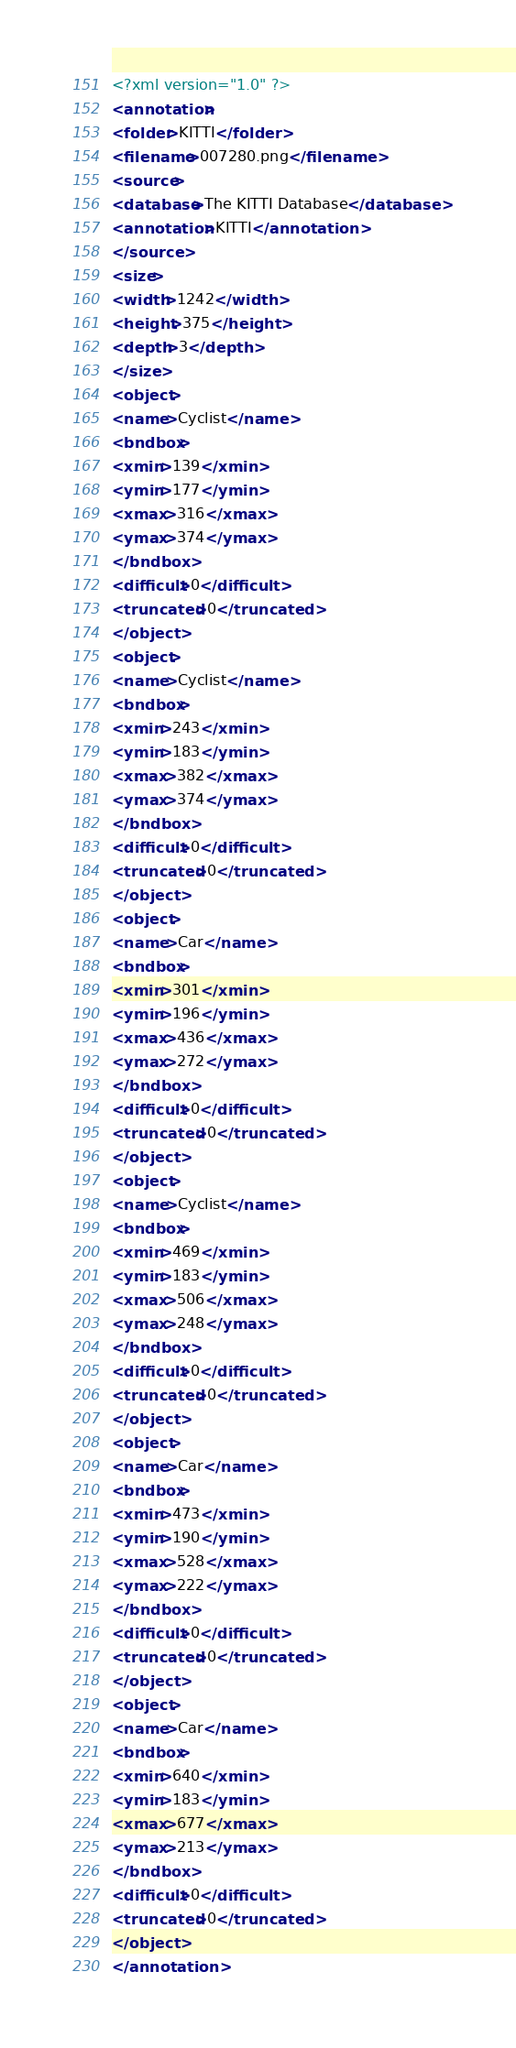Convert code to text. <code><loc_0><loc_0><loc_500><loc_500><_XML_><?xml version="1.0" ?>
<annotation>
<folder>KITTI</folder>
<filename>007280.png</filename>
<source>
<database>The KITTI Database</database>
<annotation>KITTI</annotation>
</source>
<size>
<width>1242</width>
<height>375</height>
<depth>3</depth>
</size>
<object>
<name>Cyclist</name>
<bndbox>
<xmin>139</xmin>
<ymin>177</ymin>
<xmax>316</xmax>
<ymax>374</ymax>
</bndbox>
<difficult>0</difficult>
<truncated>0</truncated>
</object>
<object>
<name>Cyclist</name>
<bndbox>
<xmin>243</xmin>
<ymin>183</ymin>
<xmax>382</xmax>
<ymax>374</ymax>
</bndbox>
<difficult>0</difficult>
<truncated>0</truncated>
</object>
<object>
<name>Car</name>
<bndbox>
<xmin>301</xmin>
<ymin>196</ymin>
<xmax>436</xmax>
<ymax>272</ymax>
</bndbox>
<difficult>0</difficult>
<truncated>0</truncated>
</object>
<object>
<name>Cyclist</name>
<bndbox>
<xmin>469</xmin>
<ymin>183</ymin>
<xmax>506</xmax>
<ymax>248</ymax>
</bndbox>
<difficult>0</difficult>
<truncated>0</truncated>
</object>
<object>
<name>Car</name>
<bndbox>
<xmin>473</xmin>
<ymin>190</ymin>
<xmax>528</xmax>
<ymax>222</ymax>
</bndbox>
<difficult>0</difficult>
<truncated>0</truncated>
</object>
<object>
<name>Car</name>
<bndbox>
<xmin>640</xmin>
<ymin>183</ymin>
<xmax>677</xmax>
<ymax>213</ymax>
</bndbox>
<difficult>0</difficult>
<truncated>0</truncated>
</object>
</annotation>
</code> 